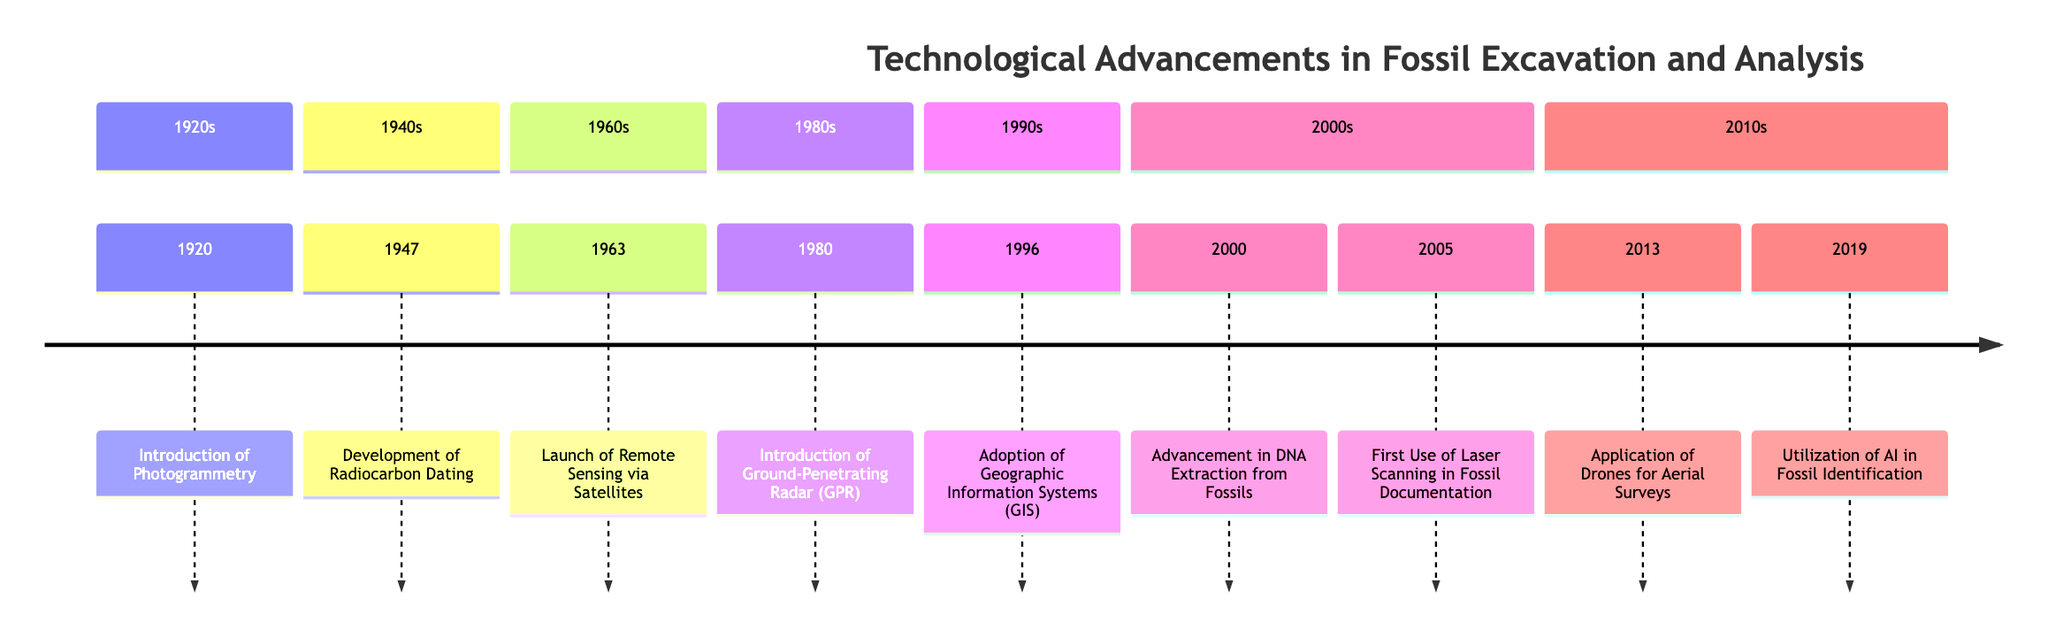What year was the introduction of photogrammetry? The diagram lists the year of the introduction of photogrammetry as 1920.
Answer: 1920 What event was associated with the year 2005? According to the timeline, the event associated with the year 2005 is the first use of laser scanning in fossil documentation.
Answer: First Use of Laser Scanning in Fossil Documentation How many events occurred in the 1980s? The timeline shows one event listed in the 1980s, which is the introduction of ground-penetrating radar in 1980.
Answer: 1 Which technology was adopted in the 1990s? The timeline details the adoption of Geographic Information Systems (GIS) in 1996, which is the sole event listed for the 1990s.
Answer: Adoption of Geographic Information Systems (GIS) What are the two significant advancements in fossil analysis that took place in the 2000s? The timeline highlights advancement in DNA extraction from fossils in 2000 and the first use of laser scanning in fossil documentation in 2005 in the 2000s. Therefore, both advancements are crucial.
Answer: Advancement in DNA Extraction from Fossils, First Use of Laser Scanning in Fossil Documentation What technological advancement occurred just before the utilization of AI in fossil identification? The diagram indicates that the application of drones for aerial surveys occurred in 2013, just before the utilization of AI in fossil identification in 2019.
Answer: Application of Drones for Aerial Surveys What decade saw the development of radiocarbon dating? The timeline shows that the development of radiocarbon dating took place in the 1940s, specifically in the year 1947.
Answer: 1940s Which decade marks the introduction of ground-penetrating radar? The timeline indicates the introduction of ground-penetrating radar occurred in the 1980s, specifically in the year 1980.
Answer: 1980s What advancement did paleontologists begin to utilize in 2019? The timeline shows that in 2019, paleontologists began to utilize artificial intelligence in fossil identification.
Answer: Utilization of Artificial Intelligence in Fossil Identification 